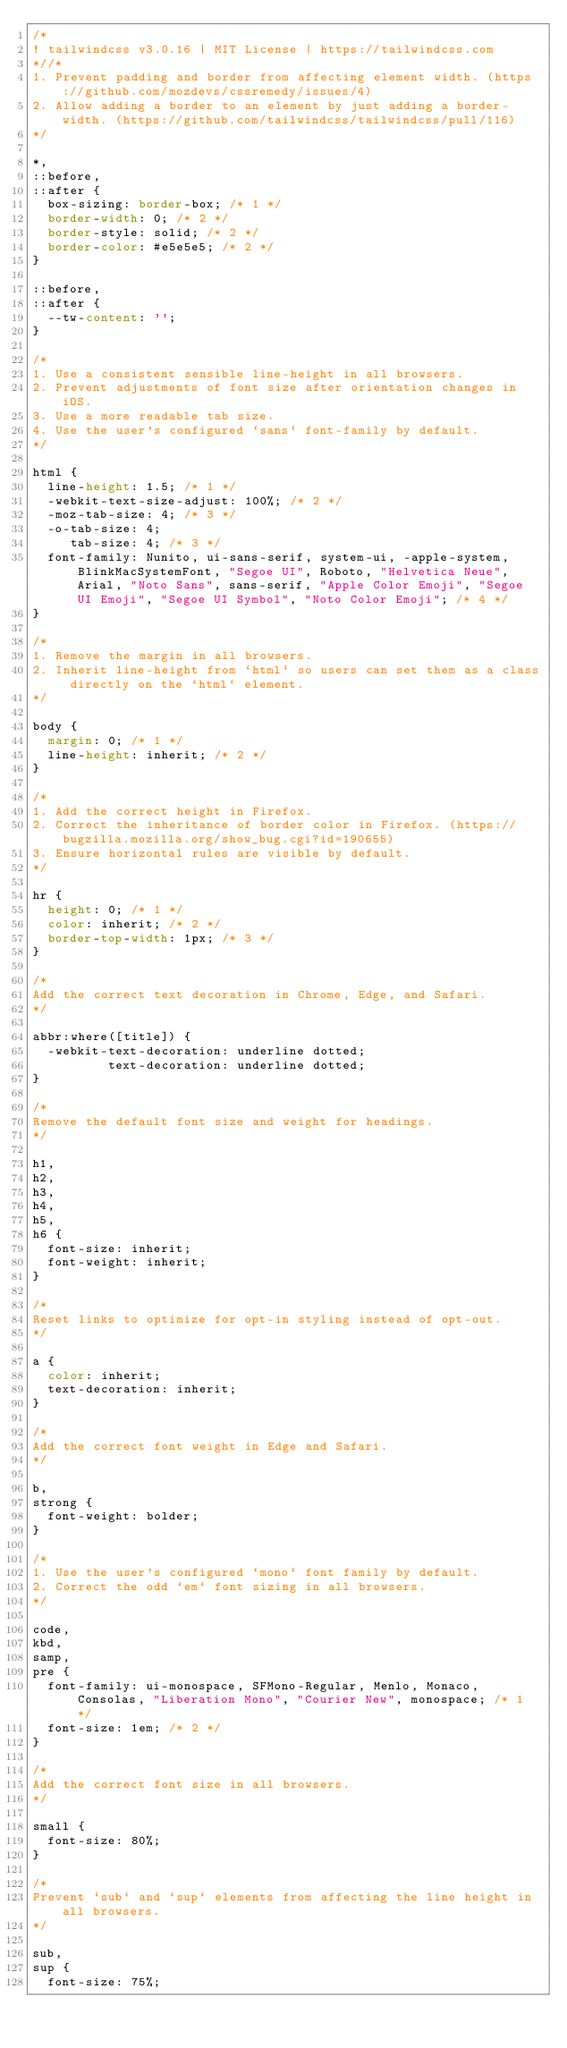Convert code to text. <code><loc_0><loc_0><loc_500><loc_500><_CSS_>/*
! tailwindcss v3.0.16 | MIT License | https://tailwindcss.com
*//*
1. Prevent padding and border from affecting element width. (https://github.com/mozdevs/cssremedy/issues/4)
2. Allow adding a border to an element by just adding a border-width. (https://github.com/tailwindcss/tailwindcss/pull/116)
*/

*,
::before,
::after {
  box-sizing: border-box; /* 1 */
  border-width: 0; /* 2 */
  border-style: solid; /* 2 */
  border-color: #e5e5e5; /* 2 */
}

::before,
::after {
  --tw-content: '';
}

/*
1. Use a consistent sensible line-height in all browsers.
2. Prevent adjustments of font size after orientation changes in iOS.
3. Use a more readable tab size.
4. Use the user's configured `sans` font-family by default.
*/

html {
  line-height: 1.5; /* 1 */
  -webkit-text-size-adjust: 100%; /* 2 */
  -moz-tab-size: 4; /* 3 */
  -o-tab-size: 4;
     tab-size: 4; /* 3 */
  font-family: Nunito, ui-sans-serif, system-ui, -apple-system, BlinkMacSystemFont, "Segoe UI", Roboto, "Helvetica Neue", Arial, "Noto Sans", sans-serif, "Apple Color Emoji", "Segoe UI Emoji", "Segoe UI Symbol", "Noto Color Emoji"; /* 4 */
}

/*
1. Remove the margin in all browsers.
2. Inherit line-height from `html` so users can set them as a class directly on the `html` element.
*/

body {
  margin: 0; /* 1 */
  line-height: inherit; /* 2 */
}

/*
1. Add the correct height in Firefox.
2. Correct the inheritance of border color in Firefox. (https://bugzilla.mozilla.org/show_bug.cgi?id=190655)
3. Ensure horizontal rules are visible by default.
*/

hr {
  height: 0; /* 1 */
  color: inherit; /* 2 */
  border-top-width: 1px; /* 3 */
}

/*
Add the correct text decoration in Chrome, Edge, and Safari.
*/

abbr:where([title]) {
  -webkit-text-decoration: underline dotted;
          text-decoration: underline dotted;
}

/*
Remove the default font size and weight for headings.
*/

h1,
h2,
h3,
h4,
h5,
h6 {
  font-size: inherit;
  font-weight: inherit;
}

/*
Reset links to optimize for opt-in styling instead of opt-out.
*/

a {
  color: inherit;
  text-decoration: inherit;
}

/*
Add the correct font weight in Edge and Safari.
*/

b,
strong {
  font-weight: bolder;
}

/*
1. Use the user's configured `mono` font family by default.
2. Correct the odd `em` font sizing in all browsers.
*/

code,
kbd,
samp,
pre {
  font-family: ui-monospace, SFMono-Regular, Menlo, Monaco, Consolas, "Liberation Mono", "Courier New", monospace; /* 1 */
  font-size: 1em; /* 2 */
}

/*
Add the correct font size in all browsers.
*/

small {
  font-size: 80%;
}

/*
Prevent `sub` and `sup` elements from affecting the line height in all browsers.
*/

sub,
sup {
  font-size: 75%;</code> 